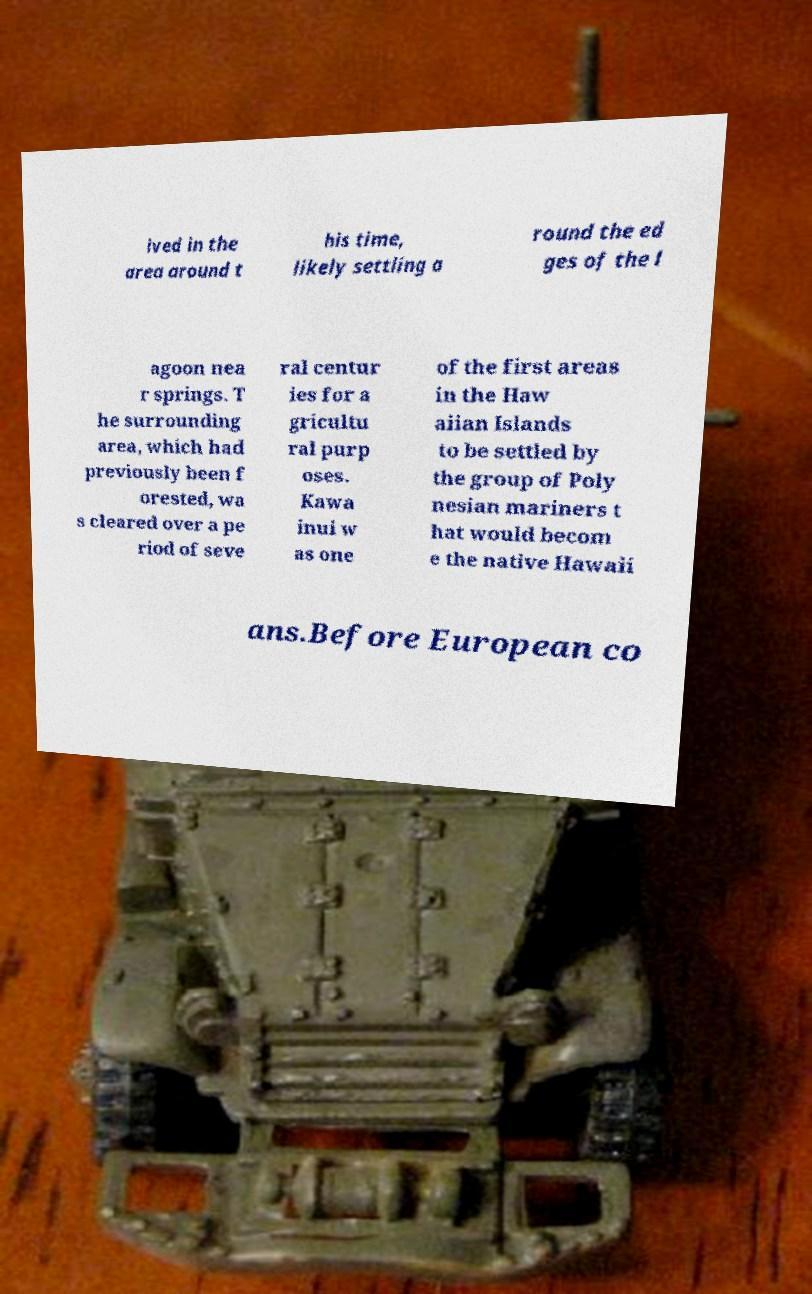Can you read and provide the text displayed in the image?This photo seems to have some interesting text. Can you extract and type it out for me? ived in the area around t his time, likely settling a round the ed ges of the l agoon nea r springs. T he surrounding area, which had previously been f orested, wa s cleared over a pe riod of seve ral centur ies for a gricultu ral purp oses. Kawa inui w as one of the first areas in the Haw aiian Islands to be settled by the group of Poly nesian mariners t hat would becom e the native Hawaii ans.Before European co 